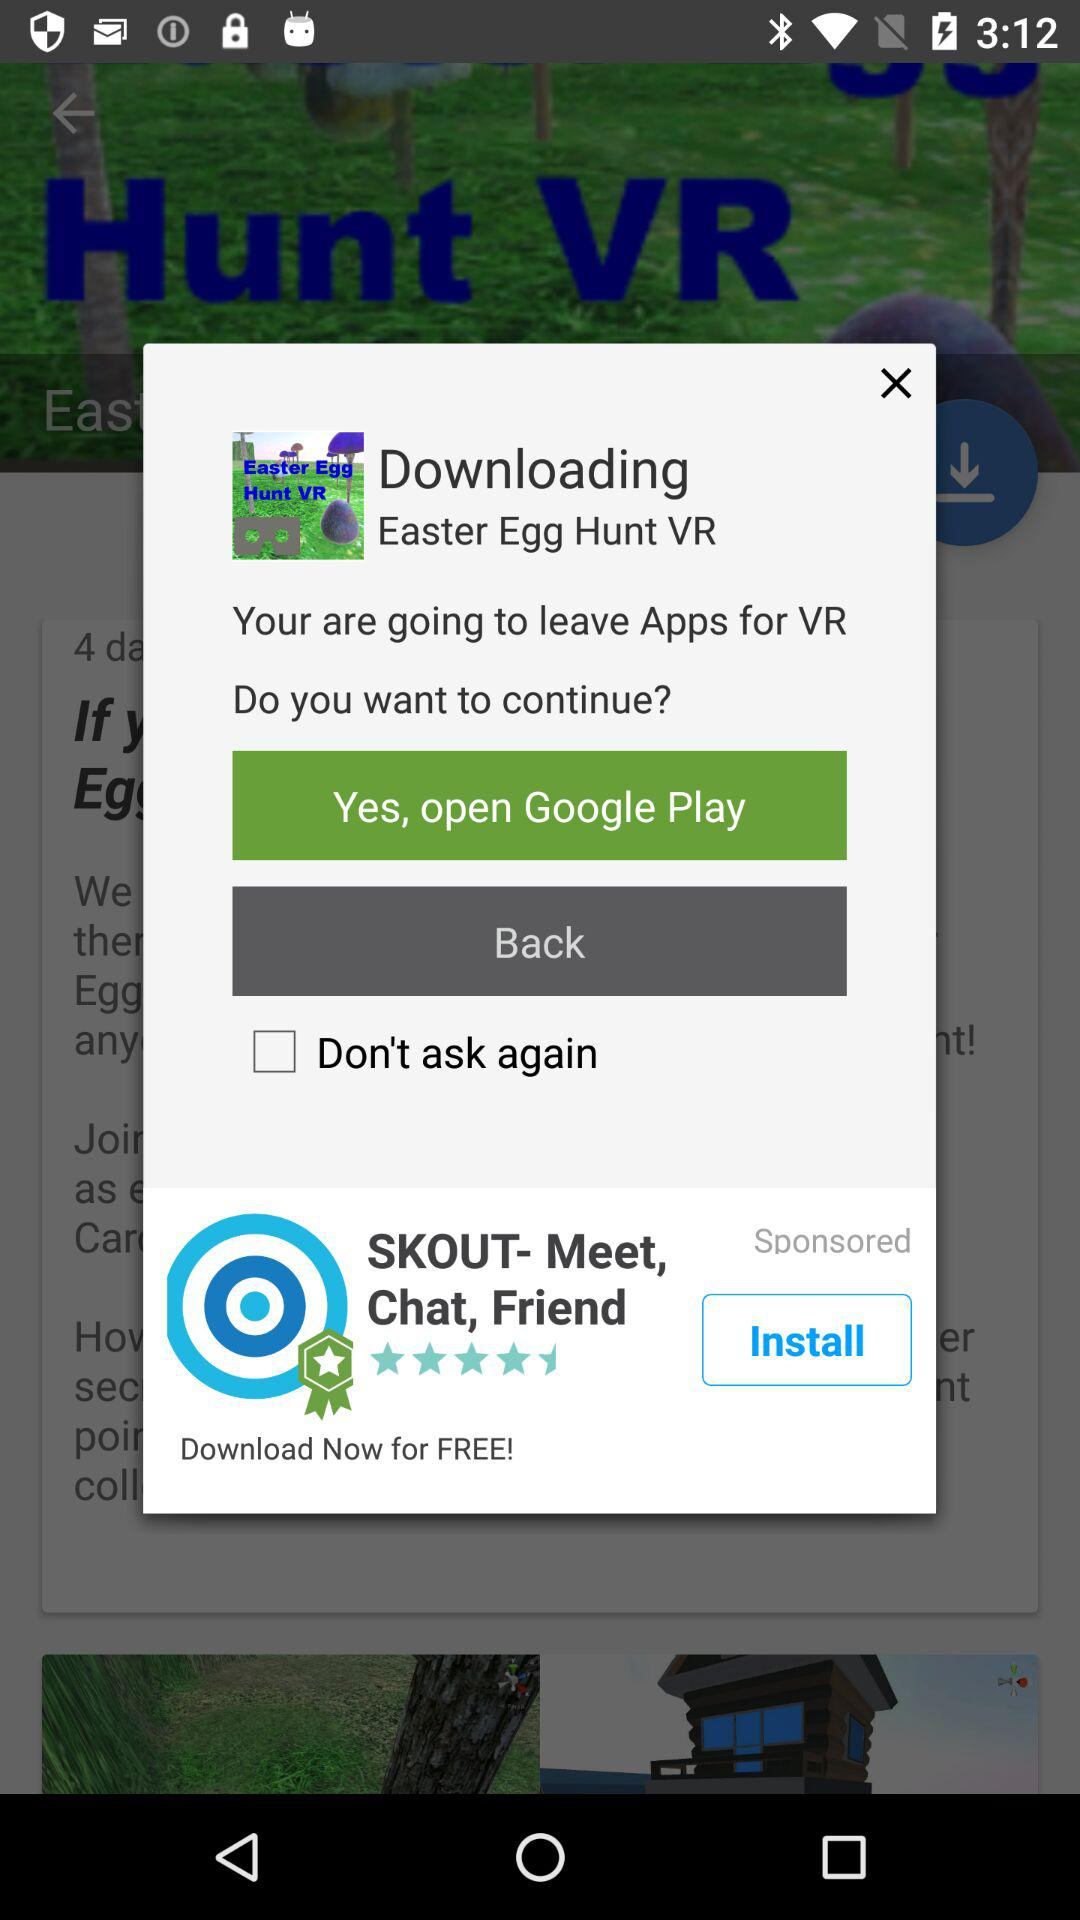What is the app name?
When the provided information is insufficient, respond with <no answer>. <no answer> 